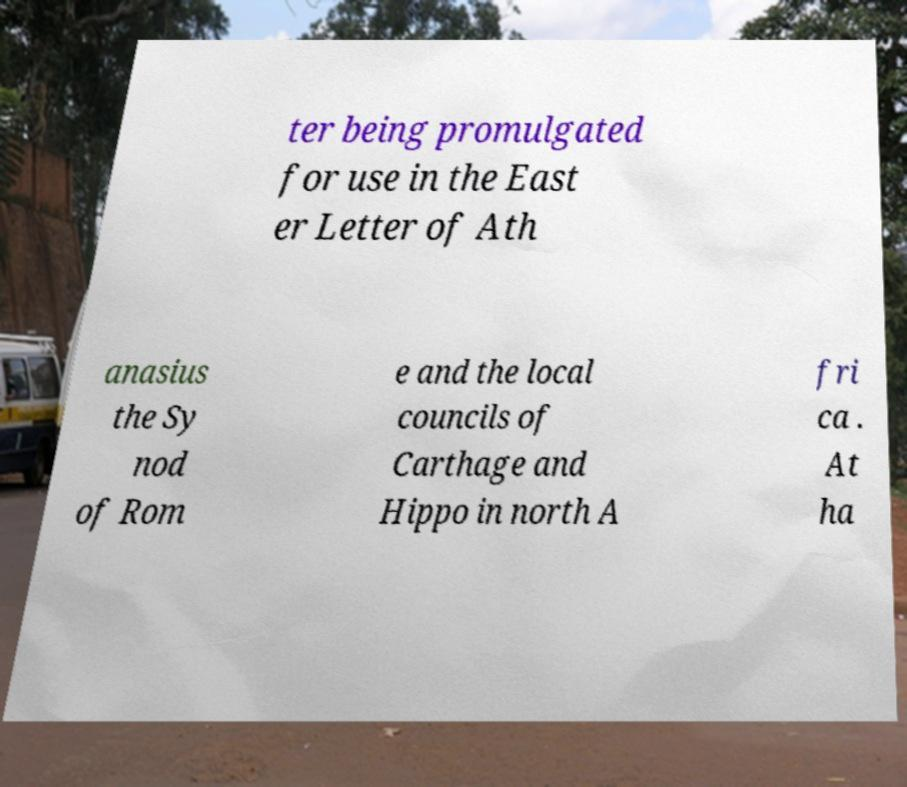For documentation purposes, I need the text within this image transcribed. Could you provide that? ter being promulgated for use in the East er Letter of Ath anasius the Sy nod of Rom e and the local councils of Carthage and Hippo in north A fri ca . At ha 